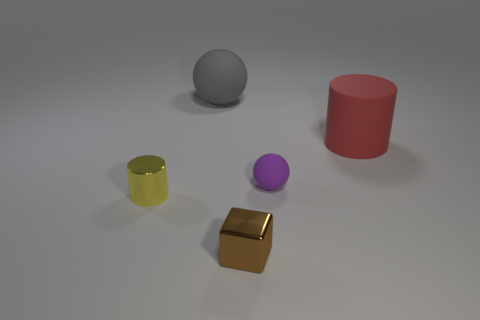Add 3 brown things. How many objects exist? 8 Subtract all cylinders. How many objects are left? 3 Subtract all tiny brown metal blocks. Subtract all small purple things. How many objects are left? 3 Add 5 shiny things. How many shiny things are left? 7 Add 2 red cylinders. How many red cylinders exist? 3 Subtract 0 red balls. How many objects are left? 5 